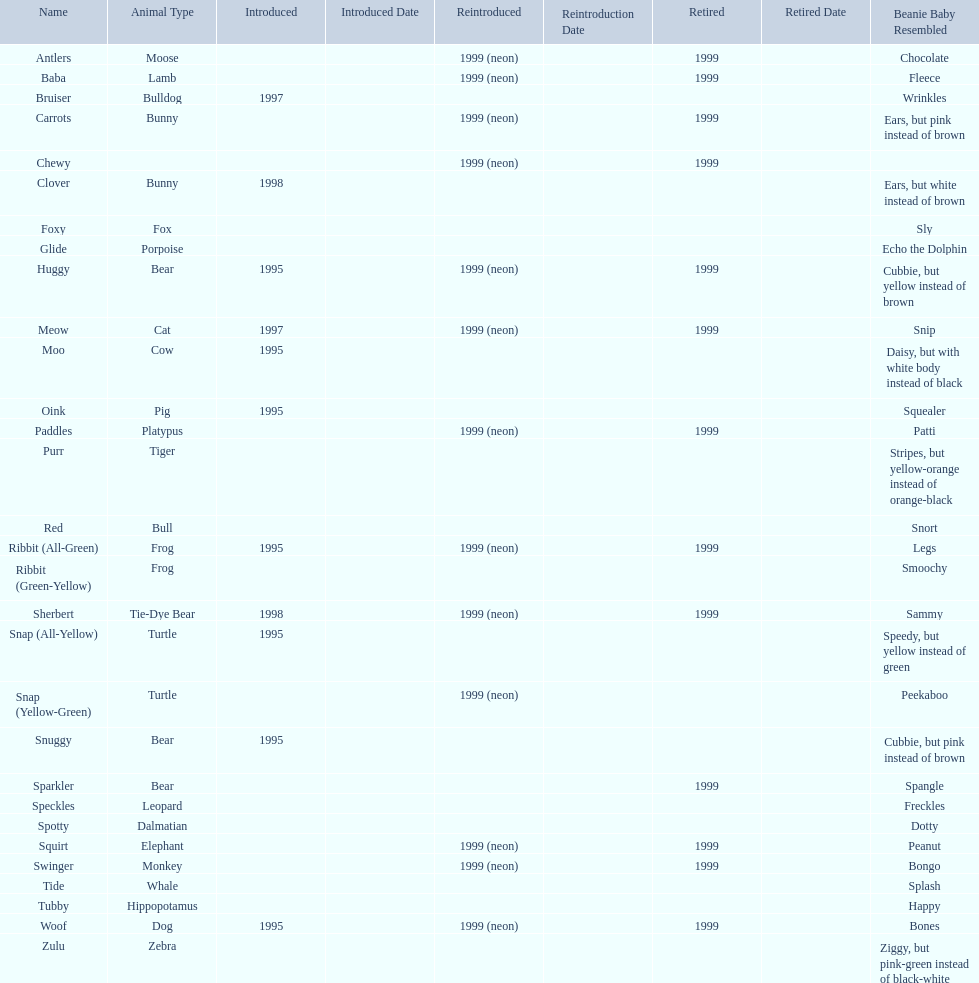Which of the listed pillow pals lack information in at least 3 categories? Chewy, Foxy, Glide, Purr, Red, Ribbit (Green-Yellow), Speckles, Spotty, Tide, Tubby, Zulu. Of those, which one lacks information in the animal type category? Chewy. 